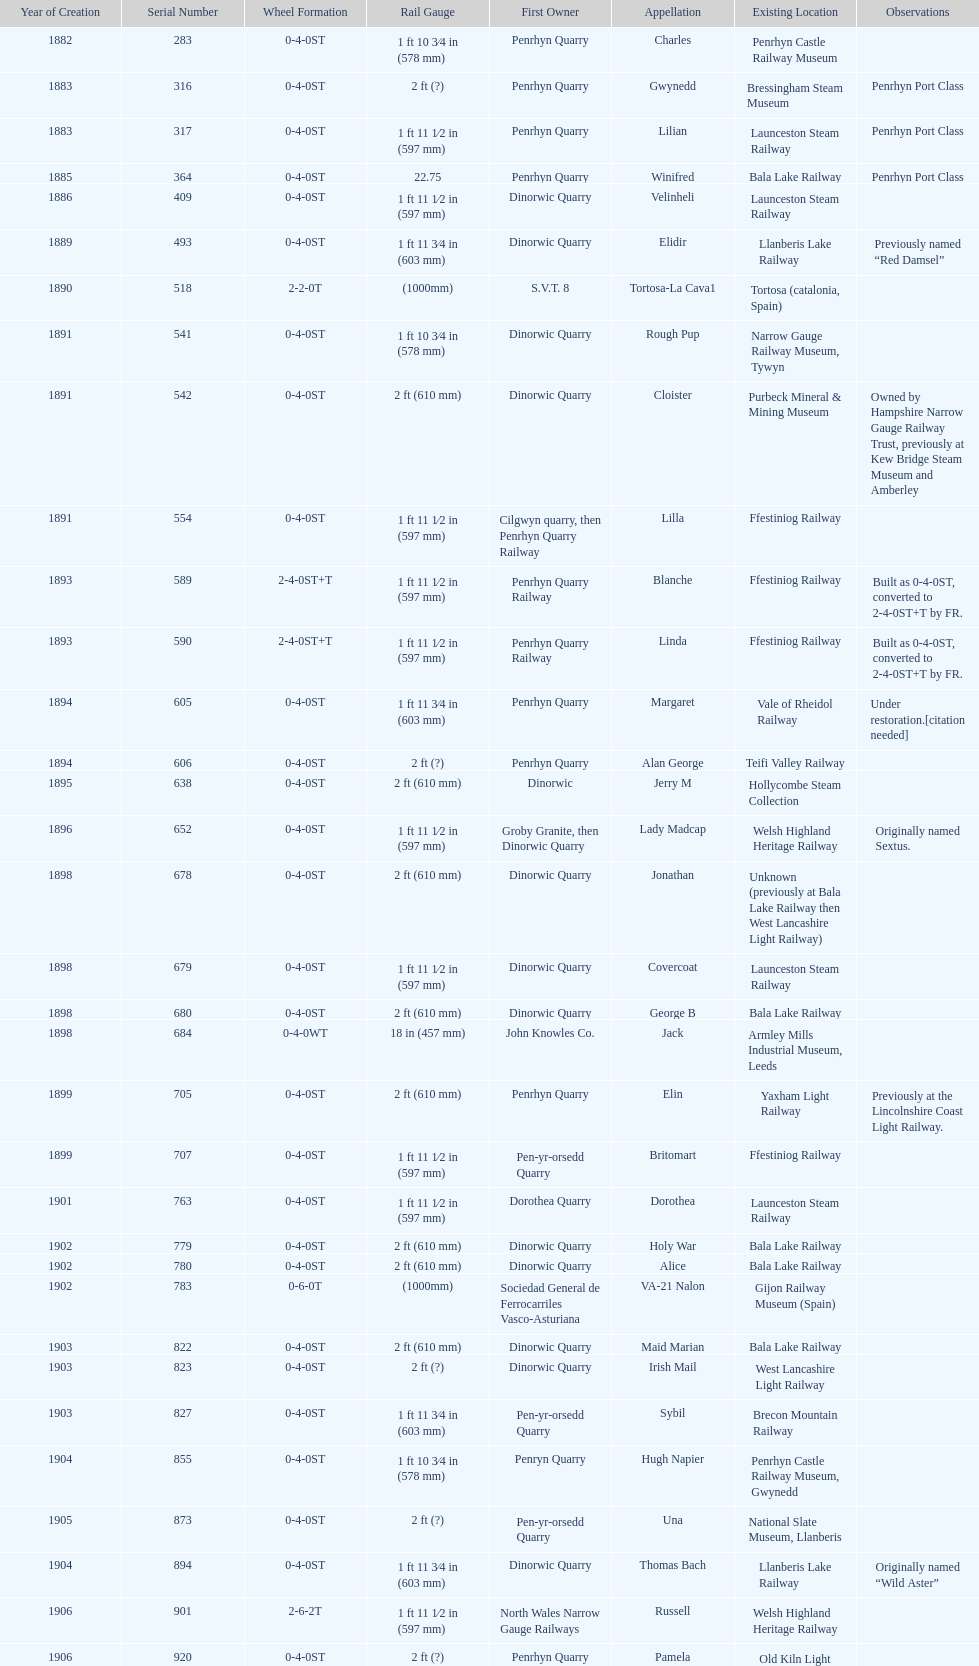After 1940, how many steam locomotives were built? 2. 